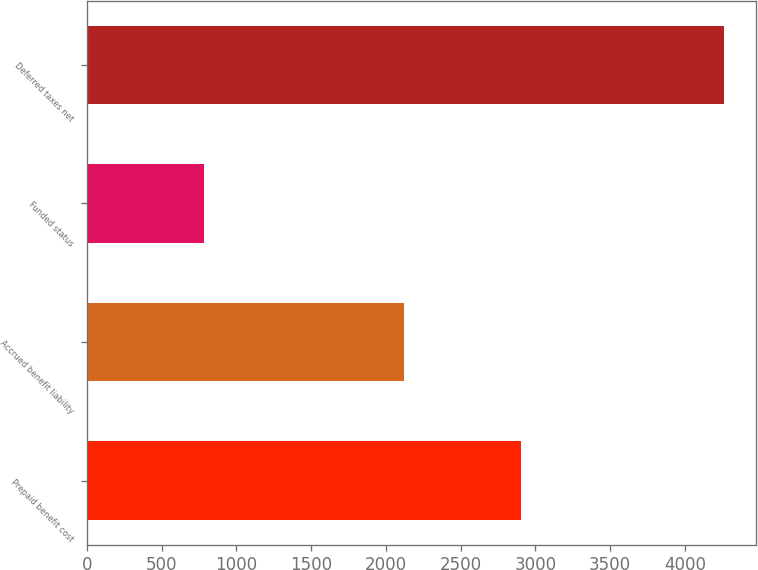Convert chart. <chart><loc_0><loc_0><loc_500><loc_500><bar_chart><fcel>Prepaid benefit cost<fcel>Accrued benefit liability<fcel>Funded status<fcel>Deferred taxes net<nl><fcel>2906<fcel>2120<fcel>786<fcel>4261<nl></chart> 